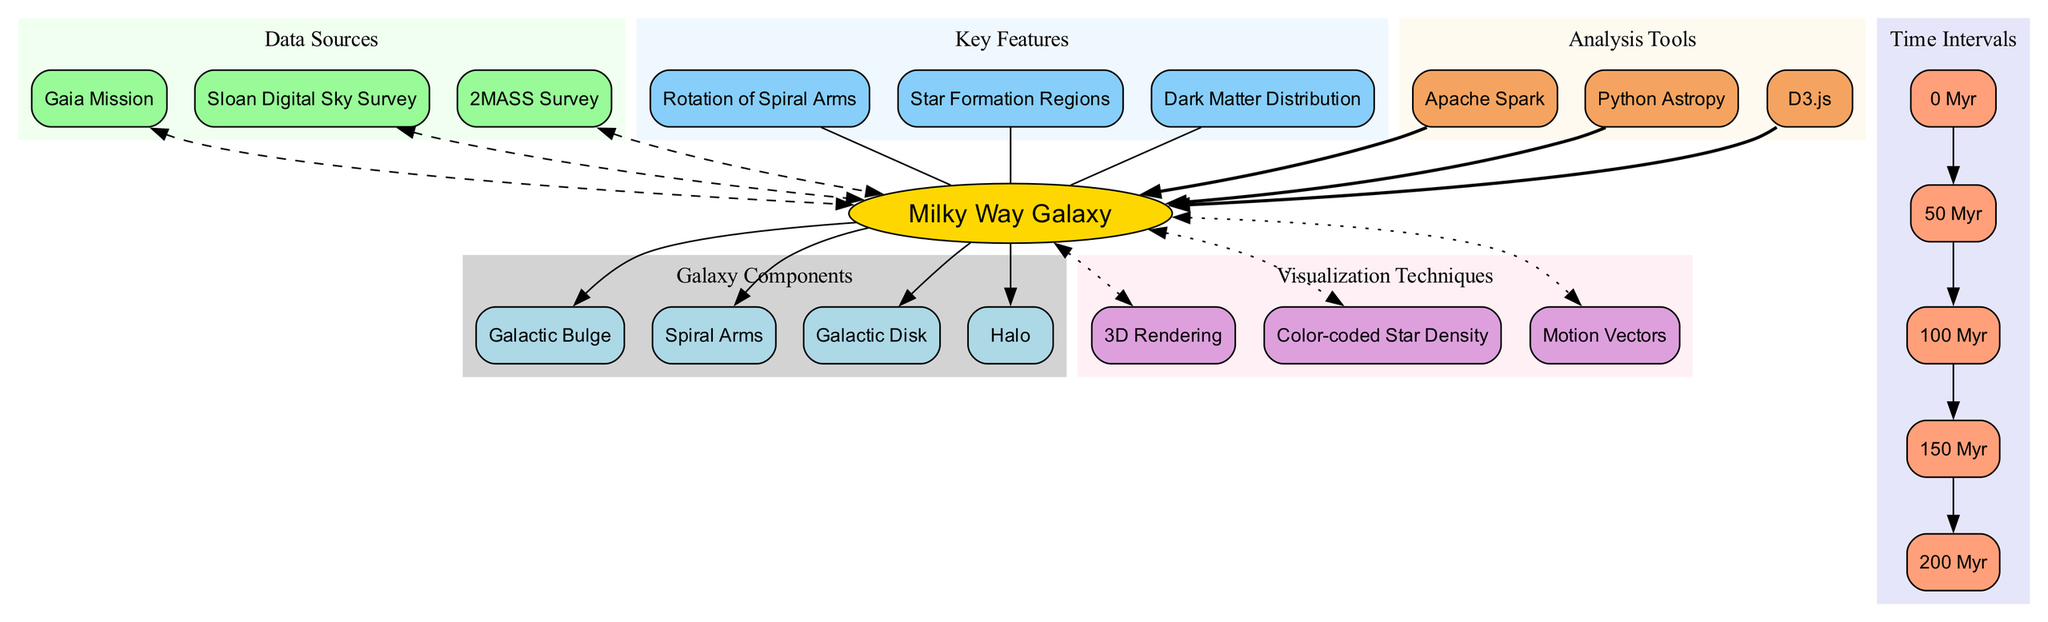What is the central object of the diagram? The diagram explicitly labels the central object as the "Milky Way Galaxy". This is typically found in the center of astronomy diagrams and serves as the focal point for other components.
Answer: Milky Way Galaxy How many components are represented in the diagram? By counting the nodes listed under the components section, there are four nodes: Galactic Bulge, Spiral Arms, Galactic Disk, and Halo. This is the total number of components directly connected to the central object.
Answer: 4 What are the time intervals depicted in the diagram? The diagram includes five time intervals: 0 Myr, 50 Myr, 100 Myr, 150 Myr, and 200 Myr. Each of these labeled nodes represents specific moments of time regarding the Milky Way's rotation.
Answer: 0 Myr, 50 Myr, 100 Myr, 150 Myr, 200 Myr Which data source is connected to the Milky Way Galaxy? The diagram shows three data sources: Gaia Mission, Sloan Digital Sky Survey, and 2MASS Survey. Each of these sources is represented as a dashed connection to the central object, indicating their role in gathering data about the Milky Way.
Answer: Gaia Mission, Sloan Digital Sky Survey, 2MASS Survey What visualization technique is used to represent star density? The diagram explicitly lists "Color-coded Star Density" as one of the visualization techniques. Each technique is represented as a connection from the central object, showing the different methodologies applied in the study.
Answer: Color-coded Star Density What key feature illustrates the distribution of dark matter? The diagram specifies "Dark Matter Distribution" as one of the key features. This information is presented in a node that is directly related to the central object, highlighting its significance in understanding the Milky Way's structure.
Answer: Dark Matter Distribution How many analysis tools are mentioned in the diagram? The diagram lists three analysis tools: Apache Spark, Python Astropy, and D3.js. Each tool is a node connected to the central object, demonstrating the variety of software used for data analysis in the study of the Milky Way.
Answer: 3 What is the relationship between the Spiral Arms and time intervals? The Spiral Arms' rotation is a feature that can be observed over the indicated time intervals, showing how they evolve over time. Thus, while not explicitly depicted, their relationship can be inferred through the time intervals progressing alongside their rotational movement.
Answer: Depends on time intervals Which component is closest to the central object in the diagram? Among the listed components connected to the central object, all are directly related but visually displayed, making the proximity uniform. However, in terms of hierarchical or visual emphasis, the Galactic Bulge is often regarded as a significant central structural feature.
Answer: Galactic Bulge 